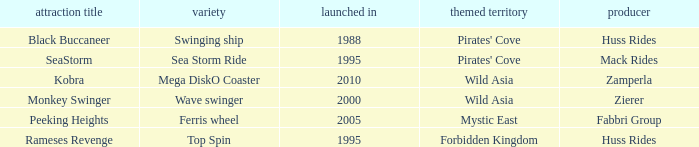What type of ride is Rameses Revenge? Top Spin. 